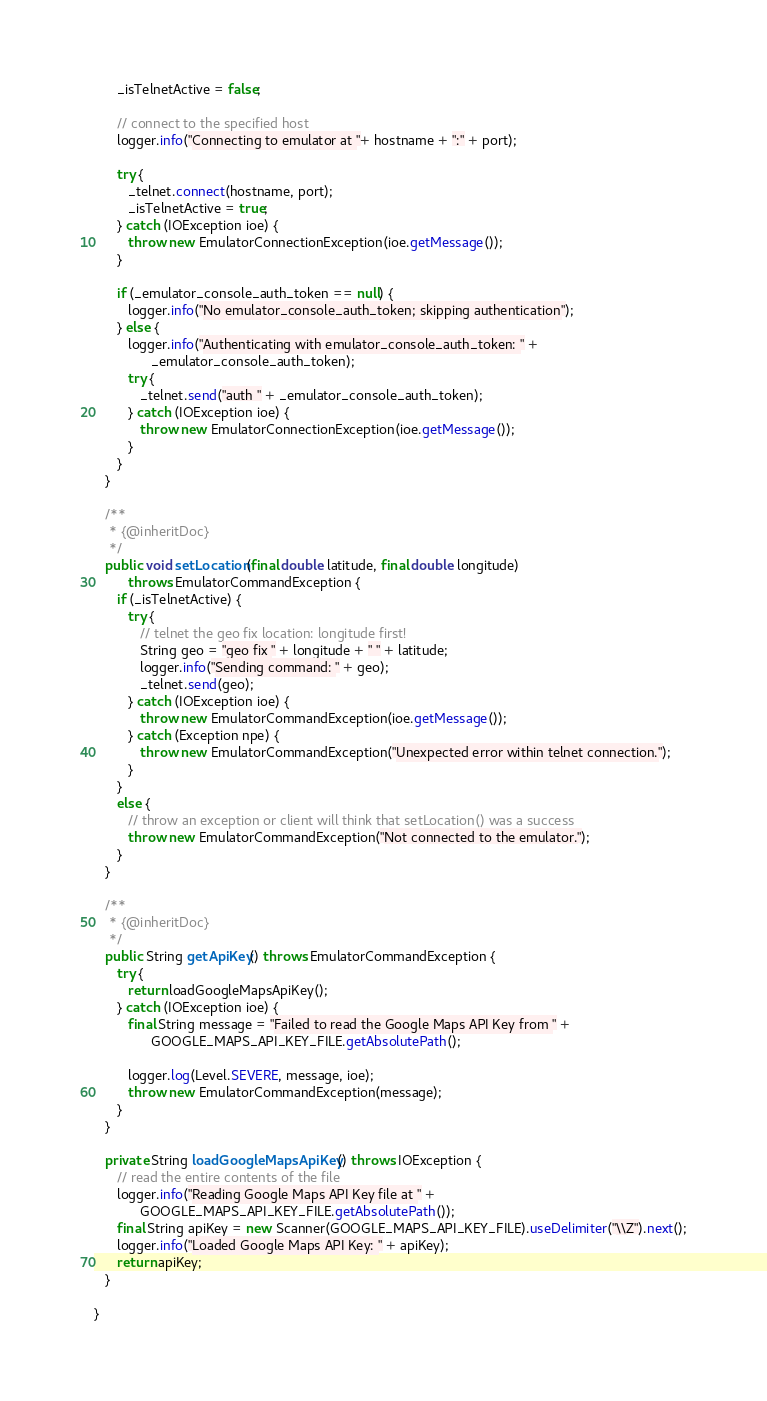<code> <loc_0><loc_0><loc_500><loc_500><_Java_>      _isTelnetActive = false;

      // connect to the specified host
      logger.info("Connecting to emulator at "+ hostname + ":" + port);

      try {
         _telnet.connect(hostname, port);
         _isTelnetActive = true;
      } catch (IOException ioe) {
         throw new EmulatorConnectionException(ioe.getMessage());
      }

      if (_emulator_console_auth_token == null) {
         logger.info("No emulator_console_auth_token; skipping authentication");
      } else {
         logger.info("Authenticating with emulator_console_auth_token: " +
               _emulator_console_auth_token);
         try {
            _telnet.send("auth " + _emulator_console_auth_token);
         } catch (IOException ioe) {
            throw new EmulatorConnectionException(ioe.getMessage());
         }
      }
   }
   
   /**
    * {@inheritDoc}
    */
   public void setLocation(final double latitude, final double longitude)
         throws EmulatorCommandException {
      if (_isTelnetActive) {
         try {
            // telnet the geo fix location: longitude first!
            String geo = "geo fix " + longitude + " " + latitude;
            logger.info("Sending command: " + geo);
            _telnet.send(geo);
         } catch (IOException ioe) {
            throw new EmulatorCommandException(ioe.getMessage());
         } catch (Exception npe) {
            throw new EmulatorCommandException("Unexpected error within telnet connection.");
         }
      }
      else {
         // throw an exception or client will think that setLocation() was a success
         throw new EmulatorCommandException("Not connected to the emulator.");
      }
   }

   /**
    * {@inheritDoc}
    */
   public String getApiKey() throws EmulatorCommandException {
      try {
         return loadGoogleMapsApiKey();
      } catch (IOException ioe) {
         final String message = "Failed to read the Google Maps API Key from " +
               GOOGLE_MAPS_API_KEY_FILE.getAbsolutePath();

         logger.log(Level.SEVERE, message, ioe);
         throw new EmulatorCommandException(message);
      }
   }

   private String loadGoogleMapsApiKey() throws IOException {
      // read the entire contents of the file
      logger.info("Reading Google Maps API Key file at " +
            GOOGLE_MAPS_API_KEY_FILE.getAbsolutePath());
      final String apiKey = new Scanner(GOOGLE_MAPS_API_KEY_FILE).useDelimiter("\\Z").next();
      logger.info("Loaded Google Maps API Key: " + apiKey);
      return apiKey;
   }

}
</code> 